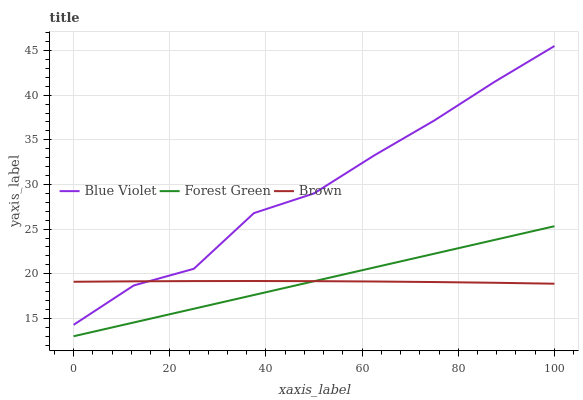Does Brown have the minimum area under the curve?
Answer yes or no. Yes. Does Blue Violet have the maximum area under the curve?
Answer yes or no. Yes. Does Forest Green have the minimum area under the curve?
Answer yes or no. No. Does Forest Green have the maximum area under the curve?
Answer yes or no. No. Is Forest Green the smoothest?
Answer yes or no. Yes. Is Blue Violet the roughest?
Answer yes or no. Yes. Is Blue Violet the smoothest?
Answer yes or no. No. Is Forest Green the roughest?
Answer yes or no. No. Does Forest Green have the lowest value?
Answer yes or no. Yes. Does Blue Violet have the lowest value?
Answer yes or no. No. Does Blue Violet have the highest value?
Answer yes or no. Yes. Does Forest Green have the highest value?
Answer yes or no. No. Is Forest Green less than Blue Violet?
Answer yes or no. Yes. Is Blue Violet greater than Forest Green?
Answer yes or no. Yes. Does Blue Violet intersect Brown?
Answer yes or no. Yes. Is Blue Violet less than Brown?
Answer yes or no. No. Is Blue Violet greater than Brown?
Answer yes or no. No. Does Forest Green intersect Blue Violet?
Answer yes or no. No. 